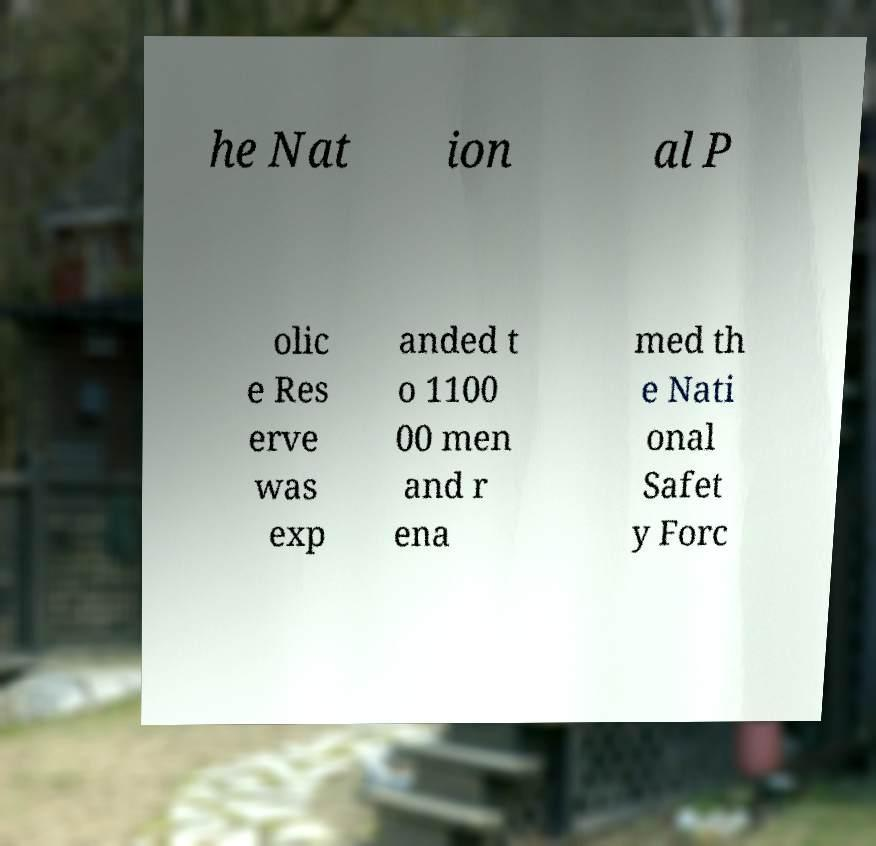Please identify and transcribe the text found in this image. he Nat ion al P olic e Res erve was exp anded t o 1100 00 men and r ena med th e Nati onal Safet y Forc 